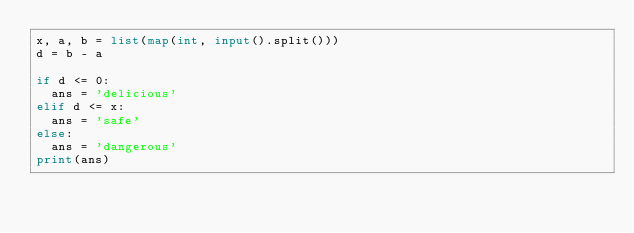<code> <loc_0><loc_0><loc_500><loc_500><_Python_>x, a, b = list(map(int, input().split()))
d = b - a

if d <= 0:
  ans = 'delicious'
elif d <= x:
  ans = 'safe'
else:
  ans = 'dangerous'
print(ans)
</code> 